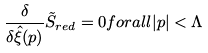Convert formula to latex. <formula><loc_0><loc_0><loc_500><loc_500>\frac { \delta } { \delta \hat { \xi } ( p ) } \tilde { S } _ { r e d } = 0 f o r a l l | p | < \Lambda</formula> 